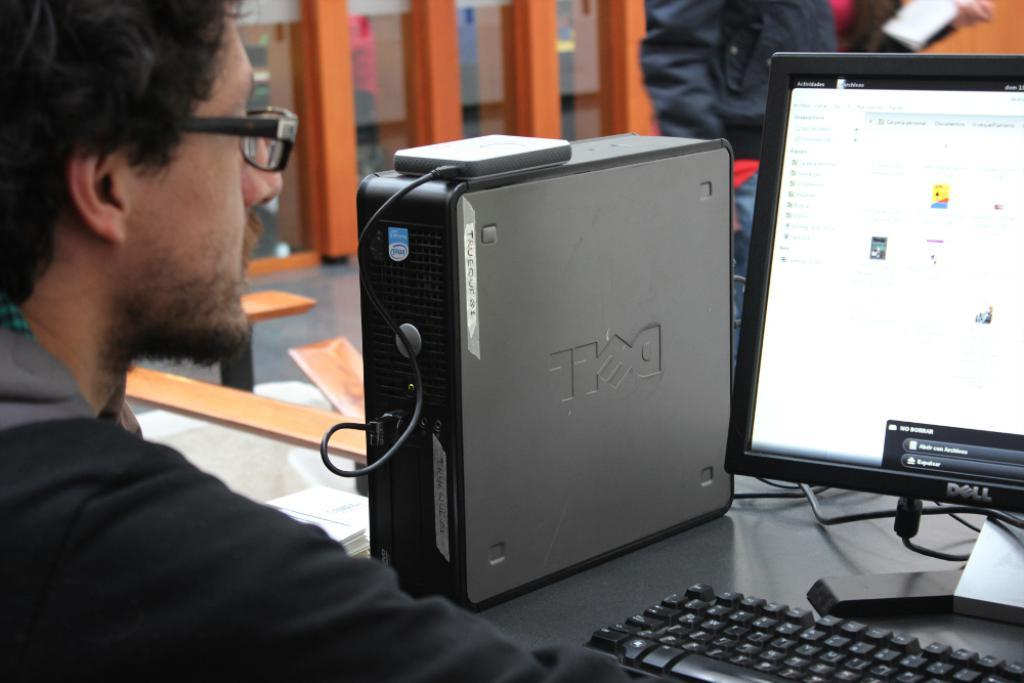<image>
Write a terse but informative summary of the picture. A man wearing glasses sits at a long table in front of a Dell computer and monitor. 